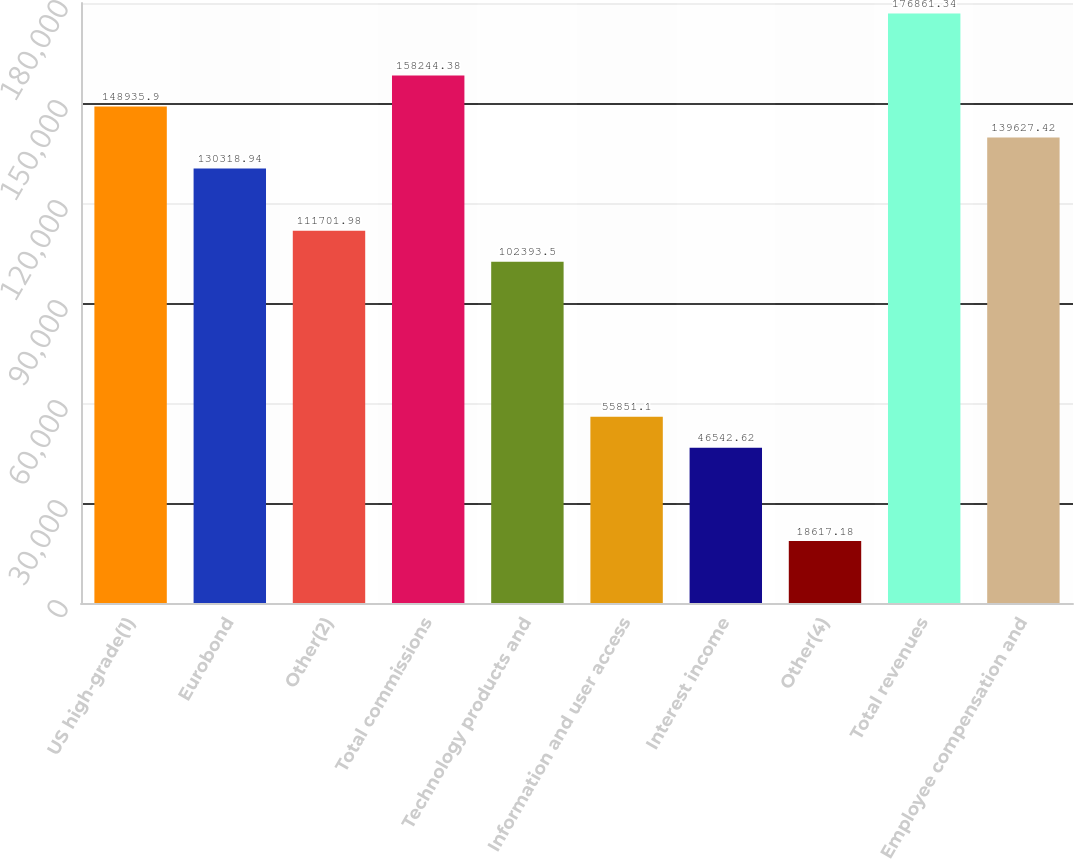Convert chart. <chart><loc_0><loc_0><loc_500><loc_500><bar_chart><fcel>US high-grade(1)<fcel>Eurobond<fcel>Other(2)<fcel>Total commissions<fcel>Technology products and<fcel>Information and user access<fcel>Interest income<fcel>Other(4)<fcel>Total revenues<fcel>Employee compensation and<nl><fcel>148936<fcel>130319<fcel>111702<fcel>158244<fcel>102394<fcel>55851.1<fcel>46542.6<fcel>18617.2<fcel>176861<fcel>139627<nl></chart> 